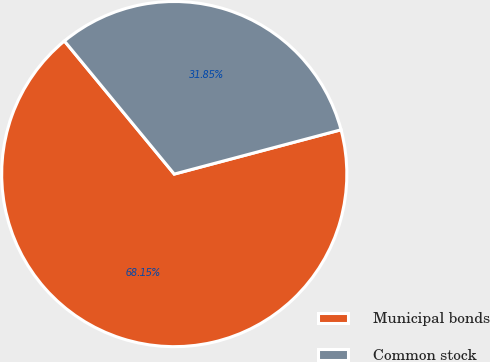Convert chart to OTSL. <chart><loc_0><loc_0><loc_500><loc_500><pie_chart><fcel>Municipal bonds<fcel>Common stock<nl><fcel>68.15%<fcel>31.85%<nl></chart> 